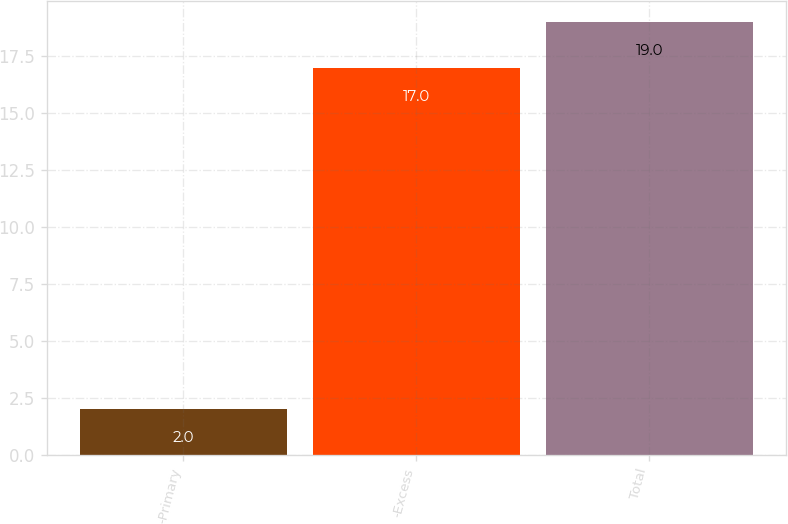Convert chart to OTSL. <chart><loc_0><loc_0><loc_500><loc_500><bar_chart><fcel>-Primary<fcel>-Excess<fcel>Total<nl><fcel>2<fcel>17<fcel>19<nl></chart> 